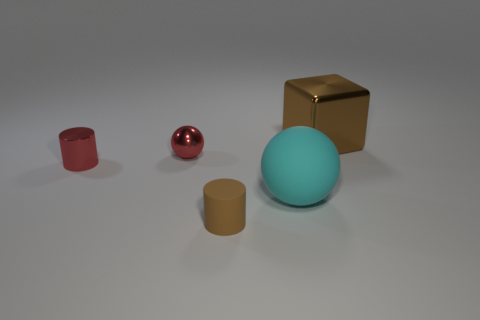Add 3 cyan metal things. How many objects exist? 8 Subtract all cyan spheres. How many spheres are left? 1 Subtract 1 cylinders. How many cylinders are left? 1 Subtract all spheres. How many objects are left? 3 Subtract all small gray balls. Subtract all small metallic cylinders. How many objects are left? 4 Add 2 shiny cylinders. How many shiny cylinders are left? 3 Add 3 red shiny spheres. How many red shiny spheres exist? 4 Subtract 1 cyan balls. How many objects are left? 4 Subtract all red spheres. Subtract all red cubes. How many spheres are left? 1 